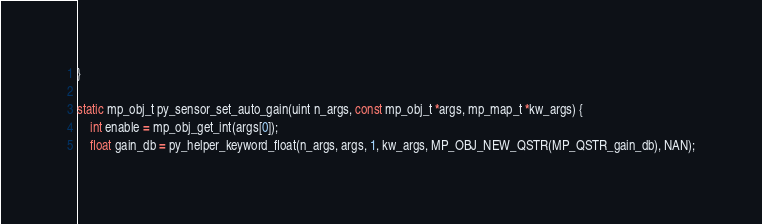<code> <loc_0><loc_0><loc_500><loc_500><_C_>}

static mp_obj_t py_sensor_set_auto_gain(uint n_args, const mp_obj_t *args, mp_map_t *kw_args) {
    int enable = mp_obj_get_int(args[0]);
    float gain_db = py_helper_keyword_float(n_args, args, 1, kw_args, MP_OBJ_NEW_QSTR(MP_QSTR_gain_db), NAN);</code> 